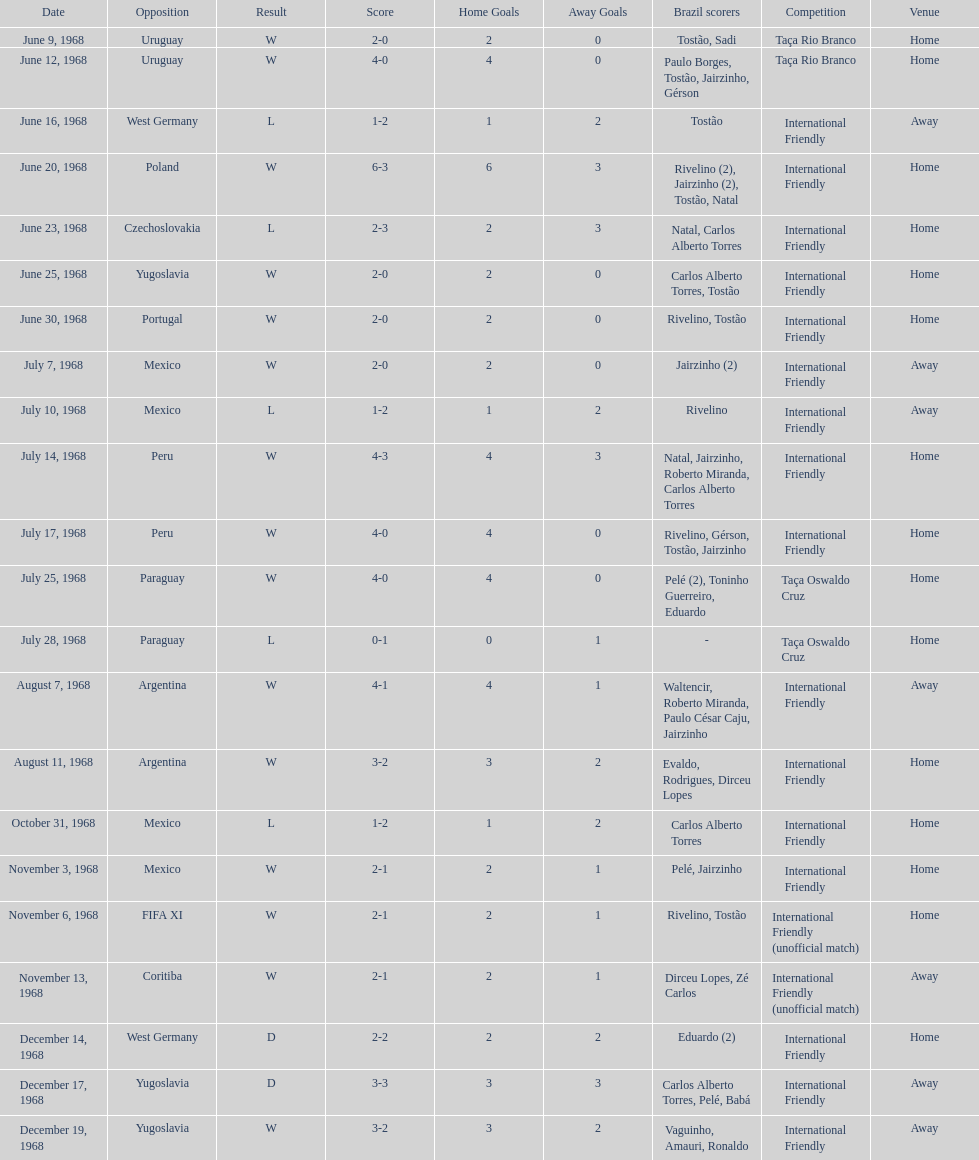How many times did brazil compete against argentina in the international friendly tournament? 2. 